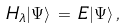<formula> <loc_0><loc_0><loc_500><loc_500>H _ { \lambda } | \Psi \rangle \, = \, E | \Psi \rangle \, ,</formula> 